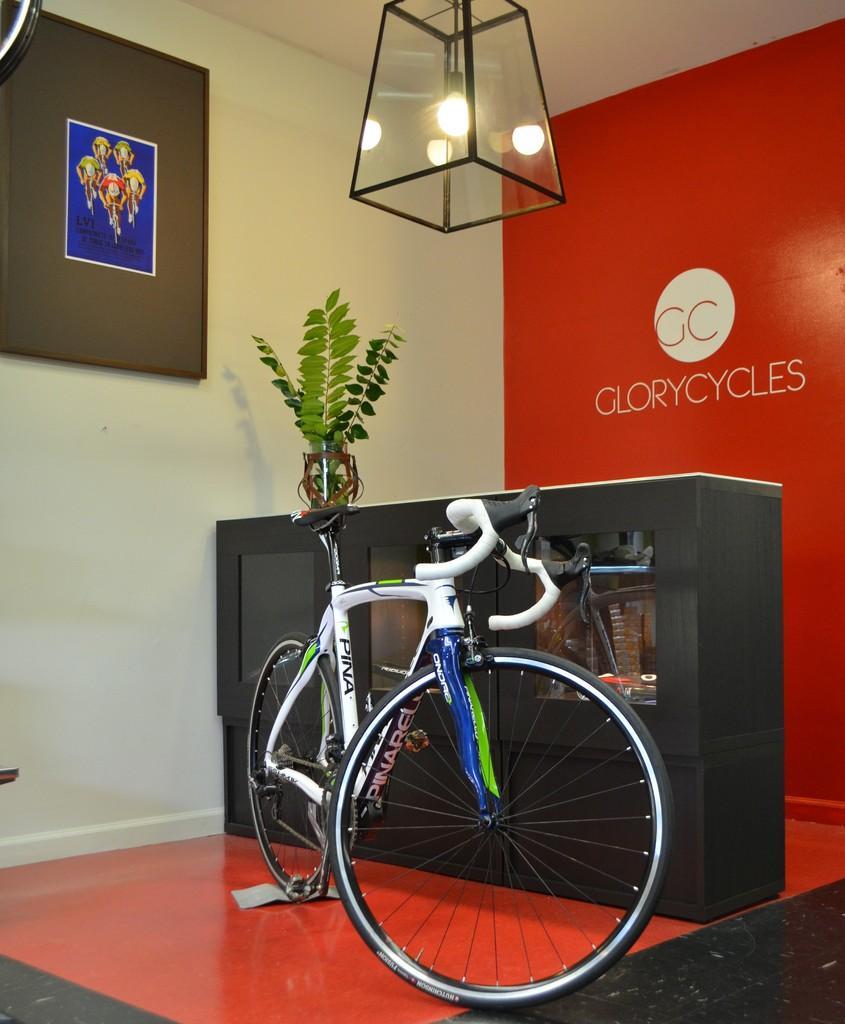Describe this image in one or two sentences. Here in this picture in the front we can see a bicycle present on the floor and behind that we can see a counter present and in the racks of it we can see something's present and on the left side, on the wall we can see a portrait present and on the top we can see a light present and on the right side we can see the wall is covered and some text is written on it over there. 